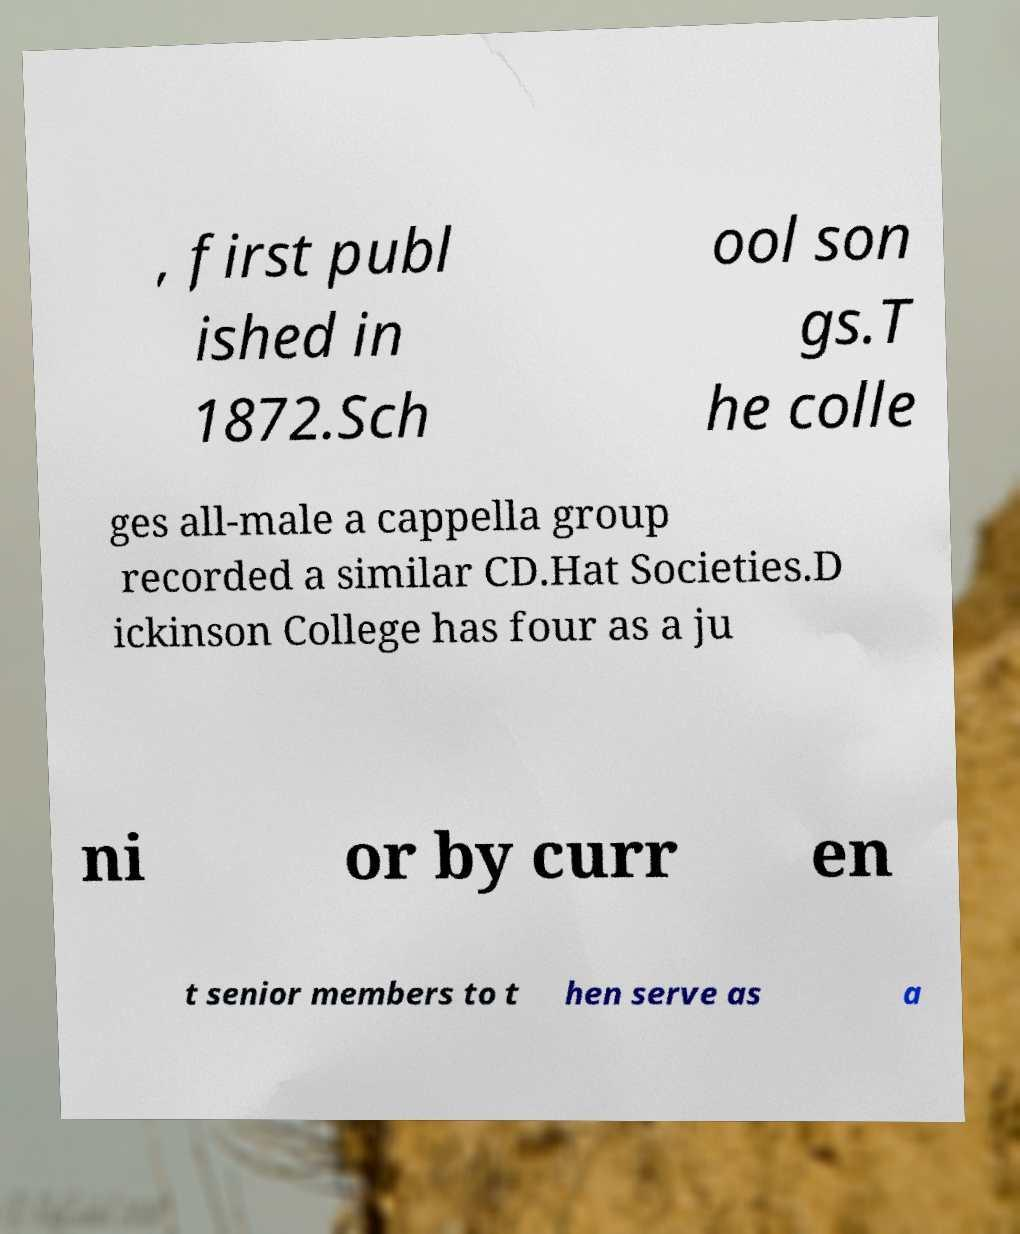Please read and relay the text visible in this image. What does it say? , first publ ished in 1872.Sch ool son gs.T he colle ges all-male a cappella group recorded a similar CD.Hat Societies.D ickinson College has four as a ju ni or by curr en t senior members to t hen serve as a 